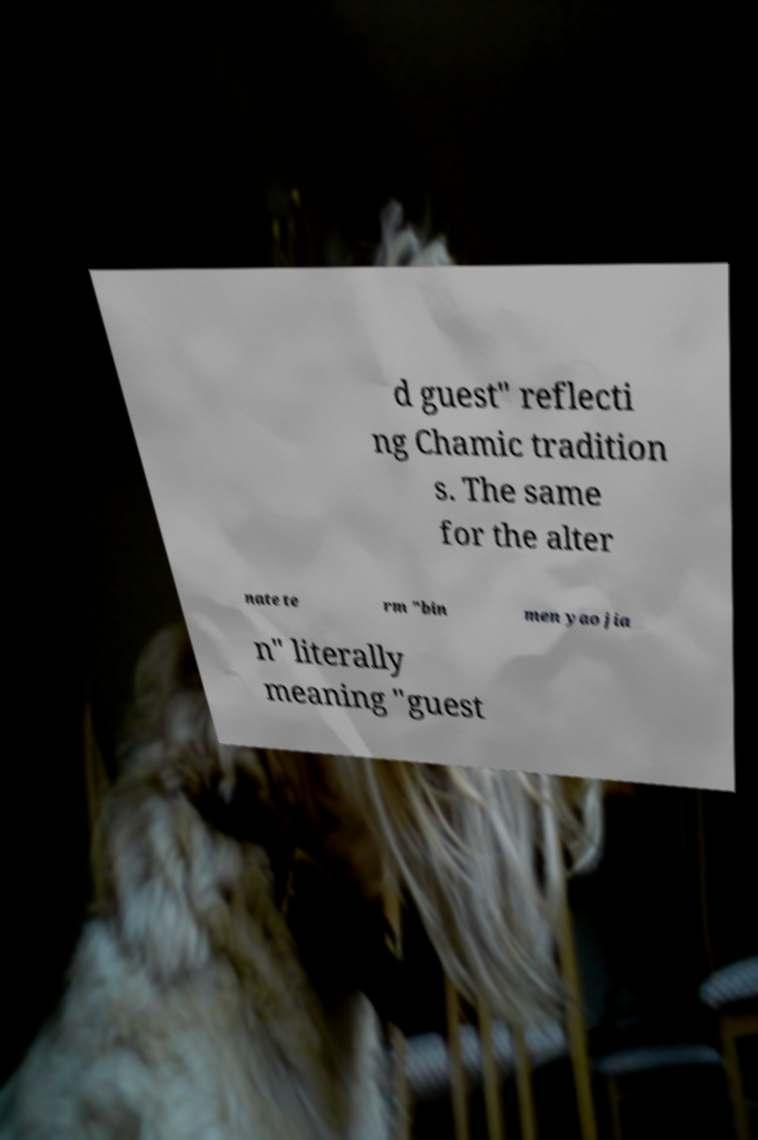There's text embedded in this image that I need extracted. Can you transcribe it verbatim? d guest" reflecti ng Chamic tradition s. The same for the alter nate te rm "bin men yao jia n" literally meaning "guest 